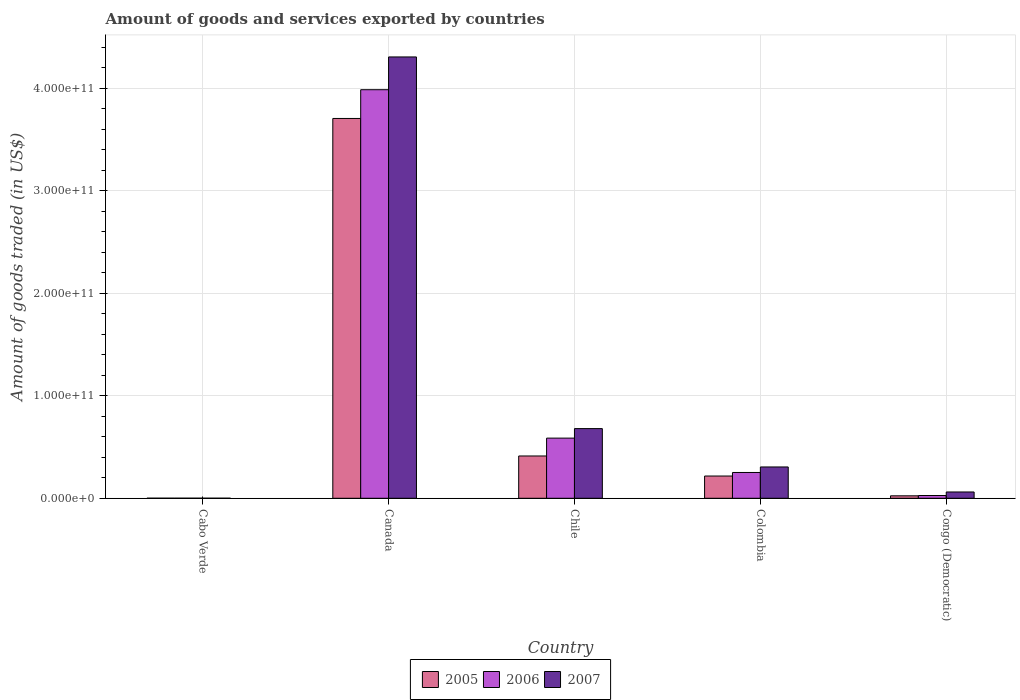Are the number of bars per tick equal to the number of legend labels?
Keep it short and to the point. Yes. How many bars are there on the 5th tick from the left?
Ensure brevity in your answer.  3. What is the label of the 5th group of bars from the left?
Offer a terse response. Congo (Democratic). In how many cases, is the number of bars for a given country not equal to the number of legend labels?
Keep it short and to the point. 0. What is the total amount of goods and services exported in 2006 in Cabo Verde?
Make the answer very short. 8.58e+07. Across all countries, what is the maximum total amount of goods and services exported in 2006?
Provide a succinct answer. 3.99e+11. Across all countries, what is the minimum total amount of goods and services exported in 2005?
Provide a short and direct response. 7.71e+07. In which country was the total amount of goods and services exported in 2005 maximum?
Your response must be concise. Canada. In which country was the total amount of goods and services exported in 2005 minimum?
Make the answer very short. Cabo Verde. What is the total total amount of goods and services exported in 2006 in the graph?
Offer a very short reply. 4.85e+11. What is the difference between the total amount of goods and services exported in 2005 in Cabo Verde and that in Congo (Democratic)?
Make the answer very short. -2.33e+09. What is the difference between the total amount of goods and services exported in 2007 in Cabo Verde and the total amount of goods and services exported in 2005 in Congo (Democratic)?
Offer a terse response. -2.33e+09. What is the average total amount of goods and services exported in 2005 per country?
Ensure brevity in your answer.  8.72e+1. What is the difference between the total amount of goods and services exported of/in 2005 and total amount of goods and services exported of/in 2007 in Cabo Verde?
Provide a succinct answer. 7.46e+06. In how many countries, is the total amount of goods and services exported in 2005 greater than 140000000000 US$?
Provide a short and direct response. 1. What is the ratio of the total amount of goods and services exported in 2006 in Colombia to that in Congo (Democratic)?
Make the answer very short. 9.3. Is the total amount of goods and services exported in 2006 in Chile less than that in Colombia?
Your response must be concise. No. What is the difference between the highest and the second highest total amount of goods and services exported in 2007?
Your response must be concise. 3.63e+11. What is the difference between the highest and the lowest total amount of goods and services exported in 2005?
Offer a terse response. 3.70e+11. What does the 2nd bar from the left in Chile represents?
Your answer should be very brief. 2006. What does the 1st bar from the right in Chile represents?
Your answer should be very brief. 2007. Is it the case that in every country, the sum of the total amount of goods and services exported in 2007 and total amount of goods and services exported in 2006 is greater than the total amount of goods and services exported in 2005?
Offer a very short reply. Yes. What is the difference between two consecutive major ticks on the Y-axis?
Offer a very short reply. 1.00e+11. Are the values on the major ticks of Y-axis written in scientific E-notation?
Give a very brief answer. Yes. Does the graph contain any zero values?
Provide a short and direct response. No. Does the graph contain grids?
Make the answer very short. Yes. Where does the legend appear in the graph?
Ensure brevity in your answer.  Bottom center. How are the legend labels stacked?
Keep it short and to the point. Horizontal. What is the title of the graph?
Your answer should be compact. Amount of goods and services exported by countries. Does "1969" appear as one of the legend labels in the graph?
Give a very brief answer. No. What is the label or title of the X-axis?
Your answer should be compact. Country. What is the label or title of the Y-axis?
Provide a short and direct response. Amount of goods traded (in US$). What is the Amount of goods traded (in US$) in 2005 in Cabo Verde?
Make the answer very short. 7.71e+07. What is the Amount of goods traded (in US$) in 2006 in Cabo Verde?
Make the answer very short. 8.58e+07. What is the Amount of goods traded (in US$) in 2007 in Cabo Verde?
Provide a short and direct response. 6.97e+07. What is the Amount of goods traded (in US$) in 2005 in Canada?
Provide a succinct answer. 3.70e+11. What is the Amount of goods traded (in US$) in 2006 in Canada?
Your answer should be very brief. 3.99e+11. What is the Amount of goods traded (in US$) in 2007 in Canada?
Your response must be concise. 4.30e+11. What is the Amount of goods traded (in US$) in 2005 in Chile?
Offer a terse response. 4.13e+1. What is the Amount of goods traded (in US$) in 2006 in Chile?
Keep it short and to the point. 5.87e+1. What is the Amount of goods traded (in US$) of 2007 in Chile?
Your answer should be compact. 6.80e+1. What is the Amount of goods traded (in US$) of 2005 in Colombia?
Give a very brief answer. 2.17e+1. What is the Amount of goods traded (in US$) of 2006 in Colombia?
Keep it short and to the point. 2.52e+1. What is the Amount of goods traded (in US$) in 2007 in Colombia?
Keep it short and to the point. 3.06e+1. What is the Amount of goods traded (in US$) in 2005 in Congo (Democratic)?
Ensure brevity in your answer.  2.40e+09. What is the Amount of goods traded (in US$) in 2006 in Congo (Democratic)?
Make the answer very short. 2.70e+09. What is the Amount of goods traded (in US$) in 2007 in Congo (Democratic)?
Provide a succinct answer. 6.15e+09. Across all countries, what is the maximum Amount of goods traded (in US$) in 2005?
Provide a succinct answer. 3.70e+11. Across all countries, what is the maximum Amount of goods traded (in US$) in 2006?
Keep it short and to the point. 3.99e+11. Across all countries, what is the maximum Amount of goods traded (in US$) in 2007?
Provide a short and direct response. 4.30e+11. Across all countries, what is the minimum Amount of goods traded (in US$) of 2005?
Your answer should be compact. 7.71e+07. Across all countries, what is the minimum Amount of goods traded (in US$) of 2006?
Your answer should be very brief. 8.58e+07. Across all countries, what is the minimum Amount of goods traded (in US$) of 2007?
Your answer should be very brief. 6.97e+07. What is the total Amount of goods traded (in US$) of 2005 in the graph?
Make the answer very short. 4.36e+11. What is the total Amount of goods traded (in US$) of 2006 in the graph?
Provide a succinct answer. 4.85e+11. What is the total Amount of goods traded (in US$) in 2007 in the graph?
Offer a very short reply. 5.35e+11. What is the difference between the Amount of goods traded (in US$) of 2005 in Cabo Verde and that in Canada?
Offer a terse response. -3.70e+11. What is the difference between the Amount of goods traded (in US$) of 2006 in Cabo Verde and that in Canada?
Provide a succinct answer. -3.98e+11. What is the difference between the Amount of goods traded (in US$) in 2007 in Cabo Verde and that in Canada?
Make the answer very short. -4.30e+11. What is the difference between the Amount of goods traded (in US$) in 2005 in Cabo Verde and that in Chile?
Offer a very short reply. -4.12e+1. What is the difference between the Amount of goods traded (in US$) in 2006 in Cabo Verde and that in Chile?
Provide a succinct answer. -5.86e+1. What is the difference between the Amount of goods traded (in US$) in 2007 in Cabo Verde and that in Chile?
Ensure brevity in your answer.  -6.79e+1. What is the difference between the Amount of goods traded (in US$) of 2005 in Cabo Verde and that in Colombia?
Provide a succinct answer. -2.16e+1. What is the difference between the Amount of goods traded (in US$) of 2006 in Cabo Verde and that in Colombia?
Your response must be concise. -2.51e+1. What is the difference between the Amount of goods traded (in US$) of 2007 in Cabo Verde and that in Colombia?
Your answer should be very brief. -3.05e+1. What is the difference between the Amount of goods traded (in US$) in 2005 in Cabo Verde and that in Congo (Democratic)?
Give a very brief answer. -2.33e+09. What is the difference between the Amount of goods traded (in US$) of 2006 in Cabo Verde and that in Congo (Democratic)?
Keep it short and to the point. -2.62e+09. What is the difference between the Amount of goods traded (in US$) of 2007 in Cabo Verde and that in Congo (Democratic)?
Provide a succinct answer. -6.08e+09. What is the difference between the Amount of goods traded (in US$) of 2005 in Canada and that in Chile?
Ensure brevity in your answer.  3.29e+11. What is the difference between the Amount of goods traded (in US$) of 2006 in Canada and that in Chile?
Your response must be concise. 3.40e+11. What is the difference between the Amount of goods traded (in US$) in 2007 in Canada and that in Chile?
Your response must be concise. 3.63e+11. What is the difference between the Amount of goods traded (in US$) of 2005 in Canada and that in Colombia?
Your response must be concise. 3.49e+11. What is the difference between the Amount of goods traded (in US$) of 2006 in Canada and that in Colombia?
Offer a very short reply. 3.73e+11. What is the difference between the Amount of goods traded (in US$) of 2007 in Canada and that in Colombia?
Your answer should be compact. 4.00e+11. What is the difference between the Amount of goods traded (in US$) in 2005 in Canada and that in Congo (Democratic)?
Make the answer very short. 3.68e+11. What is the difference between the Amount of goods traded (in US$) in 2006 in Canada and that in Congo (Democratic)?
Give a very brief answer. 3.96e+11. What is the difference between the Amount of goods traded (in US$) of 2007 in Canada and that in Congo (Democratic)?
Your answer should be very brief. 4.24e+11. What is the difference between the Amount of goods traded (in US$) of 2005 in Chile and that in Colombia?
Offer a very short reply. 1.96e+1. What is the difference between the Amount of goods traded (in US$) of 2006 in Chile and that in Colombia?
Your answer should be very brief. 3.35e+1. What is the difference between the Amount of goods traded (in US$) of 2007 in Chile and that in Colombia?
Offer a very short reply. 3.74e+1. What is the difference between the Amount of goods traded (in US$) of 2005 in Chile and that in Congo (Democratic)?
Provide a short and direct response. 3.89e+1. What is the difference between the Amount of goods traded (in US$) of 2006 in Chile and that in Congo (Democratic)?
Keep it short and to the point. 5.60e+1. What is the difference between the Amount of goods traded (in US$) of 2007 in Chile and that in Congo (Democratic)?
Give a very brief answer. 6.18e+1. What is the difference between the Amount of goods traded (in US$) of 2005 in Colombia and that in Congo (Democratic)?
Make the answer very short. 1.93e+1. What is the difference between the Amount of goods traded (in US$) in 2006 in Colombia and that in Congo (Democratic)?
Provide a short and direct response. 2.25e+1. What is the difference between the Amount of goods traded (in US$) in 2007 in Colombia and that in Congo (Democratic)?
Provide a short and direct response. 2.44e+1. What is the difference between the Amount of goods traded (in US$) in 2005 in Cabo Verde and the Amount of goods traded (in US$) in 2006 in Canada?
Your answer should be compact. -3.98e+11. What is the difference between the Amount of goods traded (in US$) in 2005 in Cabo Verde and the Amount of goods traded (in US$) in 2007 in Canada?
Offer a very short reply. -4.30e+11. What is the difference between the Amount of goods traded (in US$) in 2006 in Cabo Verde and the Amount of goods traded (in US$) in 2007 in Canada?
Make the answer very short. -4.30e+11. What is the difference between the Amount of goods traded (in US$) in 2005 in Cabo Verde and the Amount of goods traded (in US$) in 2006 in Chile?
Ensure brevity in your answer.  -5.86e+1. What is the difference between the Amount of goods traded (in US$) of 2005 in Cabo Verde and the Amount of goods traded (in US$) of 2007 in Chile?
Your response must be concise. -6.79e+1. What is the difference between the Amount of goods traded (in US$) of 2006 in Cabo Verde and the Amount of goods traded (in US$) of 2007 in Chile?
Offer a terse response. -6.79e+1. What is the difference between the Amount of goods traded (in US$) of 2005 in Cabo Verde and the Amount of goods traded (in US$) of 2006 in Colombia?
Keep it short and to the point. -2.51e+1. What is the difference between the Amount of goods traded (in US$) of 2005 in Cabo Verde and the Amount of goods traded (in US$) of 2007 in Colombia?
Provide a short and direct response. -3.05e+1. What is the difference between the Amount of goods traded (in US$) of 2006 in Cabo Verde and the Amount of goods traded (in US$) of 2007 in Colombia?
Offer a very short reply. -3.05e+1. What is the difference between the Amount of goods traded (in US$) of 2005 in Cabo Verde and the Amount of goods traded (in US$) of 2006 in Congo (Democratic)?
Provide a succinct answer. -2.63e+09. What is the difference between the Amount of goods traded (in US$) in 2005 in Cabo Verde and the Amount of goods traded (in US$) in 2007 in Congo (Democratic)?
Keep it short and to the point. -6.07e+09. What is the difference between the Amount of goods traded (in US$) of 2006 in Cabo Verde and the Amount of goods traded (in US$) of 2007 in Congo (Democratic)?
Make the answer very short. -6.06e+09. What is the difference between the Amount of goods traded (in US$) of 2005 in Canada and the Amount of goods traded (in US$) of 2006 in Chile?
Keep it short and to the point. 3.12e+11. What is the difference between the Amount of goods traded (in US$) of 2005 in Canada and the Amount of goods traded (in US$) of 2007 in Chile?
Provide a short and direct response. 3.02e+11. What is the difference between the Amount of goods traded (in US$) of 2006 in Canada and the Amount of goods traded (in US$) of 2007 in Chile?
Your answer should be compact. 3.31e+11. What is the difference between the Amount of goods traded (in US$) in 2005 in Canada and the Amount of goods traded (in US$) in 2006 in Colombia?
Provide a succinct answer. 3.45e+11. What is the difference between the Amount of goods traded (in US$) of 2005 in Canada and the Amount of goods traded (in US$) of 2007 in Colombia?
Your response must be concise. 3.40e+11. What is the difference between the Amount of goods traded (in US$) in 2006 in Canada and the Amount of goods traded (in US$) in 2007 in Colombia?
Provide a short and direct response. 3.68e+11. What is the difference between the Amount of goods traded (in US$) in 2005 in Canada and the Amount of goods traded (in US$) in 2006 in Congo (Democratic)?
Give a very brief answer. 3.68e+11. What is the difference between the Amount of goods traded (in US$) in 2005 in Canada and the Amount of goods traded (in US$) in 2007 in Congo (Democratic)?
Ensure brevity in your answer.  3.64e+11. What is the difference between the Amount of goods traded (in US$) in 2006 in Canada and the Amount of goods traded (in US$) in 2007 in Congo (Democratic)?
Provide a succinct answer. 3.92e+11. What is the difference between the Amount of goods traded (in US$) of 2005 in Chile and the Amount of goods traded (in US$) of 2006 in Colombia?
Provide a short and direct response. 1.61e+1. What is the difference between the Amount of goods traded (in US$) in 2005 in Chile and the Amount of goods traded (in US$) in 2007 in Colombia?
Offer a terse response. 1.07e+1. What is the difference between the Amount of goods traded (in US$) in 2006 in Chile and the Amount of goods traded (in US$) in 2007 in Colombia?
Ensure brevity in your answer.  2.81e+1. What is the difference between the Amount of goods traded (in US$) in 2005 in Chile and the Amount of goods traded (in US$) in 2006 in Congo (Democratic)?
Provide a succinct answer. 3.86e+1. What is the difference between the Amount of goods traded (in US$) of 2005 in Chile and the Amount of goods traded (in US$) of 2007 in Congo (Democratic)?
Offer a very short reply. 3.51e+1. What is the difference between the Amount of goods traded (in US$) in 2006 in Chile and the Amount of goods traded (in US$) in 2007 in Congo (Democratic)?
Ensure brevity in your answer.  5.25e+1. What is the difference between the Amount of goods traded (in US$) of 2005 in Colombia and the Amount of goods traded (in US$) of 2006 in Congo (Democratic)?
Give a very brief answer. 1.90e+1. What is the difference between the Amount of goods traded (in US$) in 2005 in Colombia and the Amount of goods traded (in US$) in 2007 in Congo (Democratic)?
Provide a short and direct response. 1.56e+1. What is the difference between the Amount of goods traded (in US$) in 2006 in Colombia and the Amount of goods traded (in US$) in 2007 in Congo (Democratic)?
Your answer should be compact. 1.90e+1. What is the average Amount of goods traded (in US$) in 2005 per country?
Make the answer very short. 8.72e+1. What is the average Amount of goods traded (in US$) in 2006 per country?
Give a very brief answer. 9.70e+1. What is the average Amount of goods traded (in US$) in 2007 per country?
Offer a very short reply. 1.07e+11. What is the difference between the Amount of goods traded (in US$) in 2005 and Amount of goods traded (in US$) in 2006 in Cabo Verde?
Your answer should be compact. -8.69e+06. What is the difference between the Amount of goods traded (in US$) in 2005 and Amount of goods traded (in US$) in 2007 in Cabo Verde?
Ensure brevity in your answer.  7.46e+06. What is the difference between the Amount of goods traded (in US$) of 2006 and Amount of goods traded (in US$) of 2007 in Cabo Verde?
Keep it short and to the point. 1.61e+07. What is the difference between the Amount of goods traded (in US$) of 2005 and Amount of goods traded (in US$) of 2006 in Canada?
Give a very brief answer. -2.80e+1. What is the difference between the Amount of goods traded (in US$) in 2005 and Amount of goods traded (in US$) in 2007 in Canada?
Provide a short and direct response. -6.00e+1. What is the difference between the Amount of goods traded (in US$) in 2006 and Amount of goods traded (in US$) in 2007 in Canada?
Your response must be concise. -3.20e+1. What is the difference between the Amount of goods traded (in US$) of 2005 and Amount of goods traded (in US$) of 2006 in Chile?
Give a very brief answer. -1.74e+1. What is the difference between the Amount of goods traded (in US$) in 2005 and Amount of goods traded (in US$) in 2007 in Chile?
Give a very brief answer. -2.67e+1. What is the difference between the Amount of goods traded (in US$) in 2006 and Amount of goods traded (in US$) in 2007 in Chile?
Your answer should be very brief. -9.29e+09. What is the difference between the Amount of goods traded (in US$) of 2005 and Amount of goods traded (in US$) of 2006 in Colombia?
Provide a short and direct response. -3.46e+09. What is the difference between the Amount of goods traded (in US$) of 2005 and Amount of goods traded (in US$) of 2007 in Colombia?
Make the answer very short. -8.85e+09. What is the difference between the Amount of goods traded (in US$) in 2006 and Amount of goods traded (in US$) in 2007 in Colombia?
Your answer should be compact. -5.39e+09. What is the difference between the Amount of goods traded (in US$) of 2005 and Amount of goods traded (in US$) of 2006 in Congo (Democratic)?
Keep it short and to the point. -3.02e+08. What is the difference between the Amount of goods traded (in US$) of 2005 and Amount of goods traded (in US$) of 2007 in Congo (Democratic)?
Provide a short and direct response. -3.75e+09. What is the difference between the Amount of goods traded (in US$) of 2006 and Amount of goods traded (in US$) of 2007 in Congo (Democratic)?
Give a very brief answer. -3.44e+09. What is the ratio of the Amount of goods traded (in US$) in 2005 in Cabo Verde to that in Chile?
Your response must be concise. 0. What is the ratio of the Amount of goods traded (in US$) of 2006 in Cabo Verde to that in Chile?
Make the answer very short. 0. What is the ratio of the Amount of goods traded (in US$) in 2005 in Cabo Verde to that in Colombia?
Your response must be concise. 0. What is the ratio of the Amount of goods traded (in US$) in 2006 in Cabo Verde to that in Colombia?
Keep it short and to the point. 0. What is the ratio of the Amount of goods traded (in US$) in 2007 in Cabo Verde to that in Colombia?
Make the answer very short. 0. What is the ratio of the Amount of goods traded (in US$) of 2005 in Cabo Verde to that in Congo (Democratic)?
Give a very brief answer. 0.03. What is the ratio of the Amount of goods traded (in US$) in 2006 in Cabo Verde to that in Congo (Democratic)?
Offer a terse response. 0.03. What is the ratio of the Amount of goods traded (in US$) of 2007 in Cabo Verde to that in Congo (Democratic)?
Keep it short and to the point. 0.01. What is the ratio of the Amount of goods traded (in US$) of 2005 in Canada to that in Chile?
Provide a succinct answer. 8.98. What is the ratio of the Amount of goods traded (in US$) in 2006 in Canada to that in Chile?
Provide a succinct answer. 6.79. What is the ratio of the Amount of goods traded (in US$) in 2007 in Canada to that in Chile?
Ensure brevity in your answer.  6.33. What is the ratio of the Amount of goods traded (in US$) in 2005 in Canada to that in Colombia?
Your response must be concise. 17.07. What is the ratio of the Amount of goods traded (in US$) of 2006 in Canada to that in Colombia?
Make the answer very short. 15.84. What is the ratio of the Amount of goods traded (in US$) of 2007 in Canada to that in Colombia?
Make the answer very short. 14.09. What is the ratio of the Amount of goods traded (in US$) in 2005 in Canada to that in Congo (Democratic)?
Ensure brevity in your answer.  154.18. What is the ratio of the Amount of goods traded (in US$) of 2006 in Canada to that in Congo (Democratic)?
Ensure brevity in your answer.  147.34. What is the ratio of the Amount of goods traded (in US$) in 2007 in Canada to that in Congo (Democratic)?
Ensure brevity in your answer.  70.02. What is the ratio of the Amount of goods traded (in US$) of 2005 in Chile to that in Colombia?
Your answer should be very brief. 1.9. What is the ratio of the Amount of goods traded (in US$) in 2006 in Chile to that in Colombia?
Your response must be concise. 2.33. What is the ratio of the Amount of goods traded (in US$) of 2007 in Chile to that in Colombia?
Ensure brevity in your answer.  2.22. What is the ratio of the Amount of goods traded (in US$) of 2005 in Chile to that in Congo (Democratic)?
Offer a very short reply. 17.17. What is the ratio of the Amount of goods traded (in US$) in 2006 in Chile to that in Congo (Democratic)?
Your answer should be compact. 21.69. What is the ratio of the Amount of goods traded (in US$) in 2007 in Chile to that in Congo (Democratic)?
Keep it short and to the point. 11.06. What is the ratio of the Amount of goods traded (in US$) in 2005 in Colombia to that in Congo (Democratic)?
Offer a terse response. 9.03. What is the ratio of the Amount of goods traded (in US$) of 2006 in Colombia to that in Congo (Democratic)?
Your response must be concise. 9.3. What is the ratio of the Amount of goods traded (in US$) in 2007 in Colombia to that in Congo (Democratic)?
Give a very brief answer. 4.97. What is the difference between the highest and the second highest Amount of goods traded (in US$) in 2005?
Ensure brevity in your answer.  3.29e+11. What is the difference between the highest and the second highest Amount of goods traded (in US$) in 2006?
Give a very brief answer. 3.40e+11. What is the difference between the highest and the second highest Amount of goods traded (in US$) in 2007?
Offer a terse response. 3.63e+11. What is the difference between the highest and the lowest Amount of goods traded (in US$) of 2005?
Give a very brief answer. 3.70e+11. What is the difference between the highest and the lowest Amount of goods traded (in US$) of 2006?
Give a very brief answer. 3.98e+11. What is the difference between the highest and the lowest Amount of goods traded (in US$) of 2007?
Your response must be concise. 4.30e+11. 